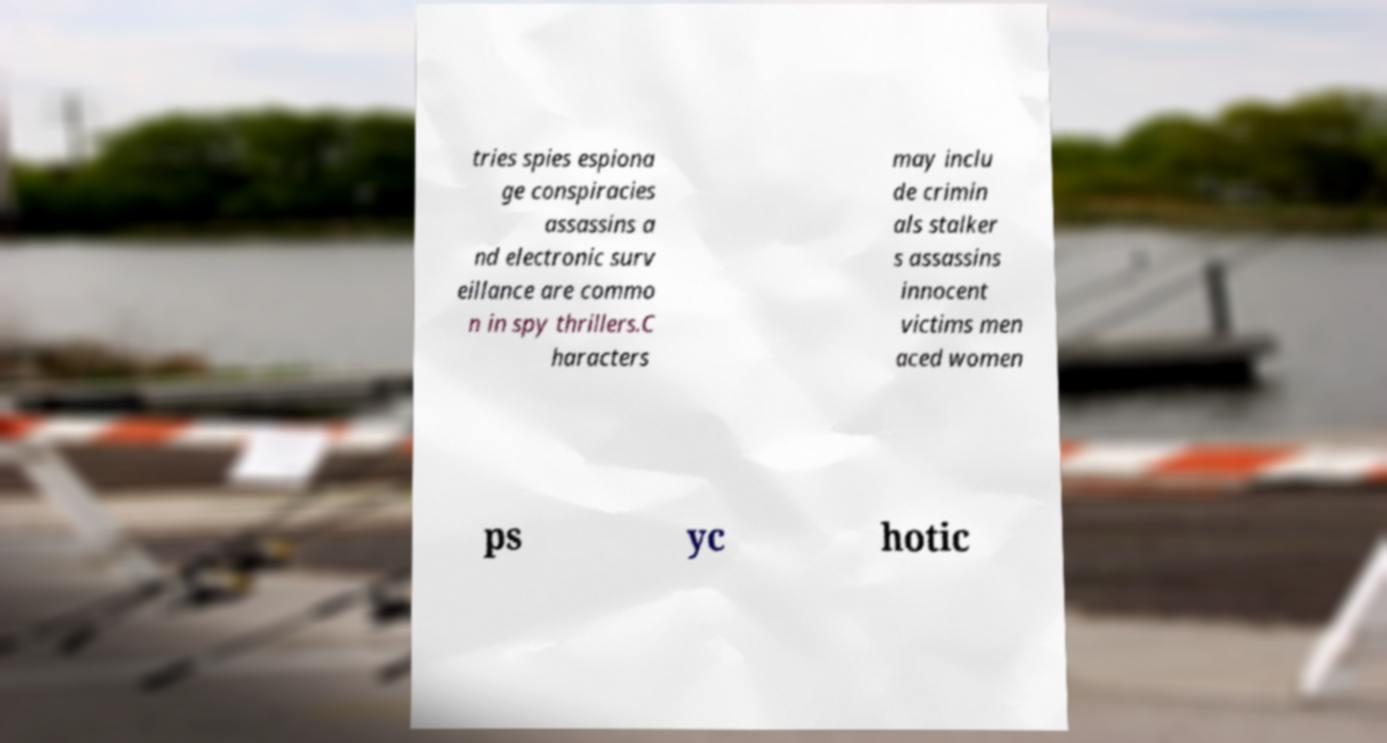I need the written content from this picture converted into text. Can you do that? tries spies espiona ge conspiracies assassins a nd electronic surv eillance are commo n in spy thrillers.C haracters may inclu de crimin als stalker s assassins innocent victims men aced women ps yc hotic 